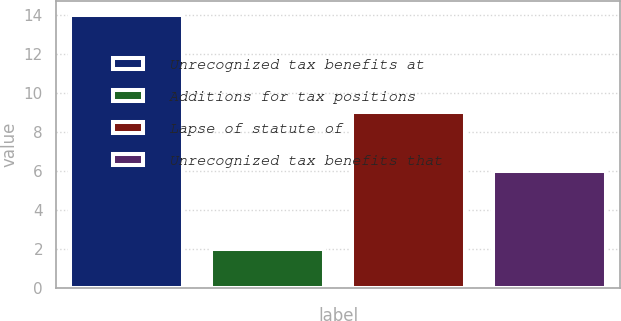<chart> <loc_0><loc_0><loc_500><loc_500><bar_chart><fcel>Unrecognized tax benefits at<fcel>Additions for tax positions<fcel>Lapse of statute of<fcel>Unrecognized tax benefits that<nl><fcel>14<fcel>2<fcel>9<fcel>6<nl></chart> 